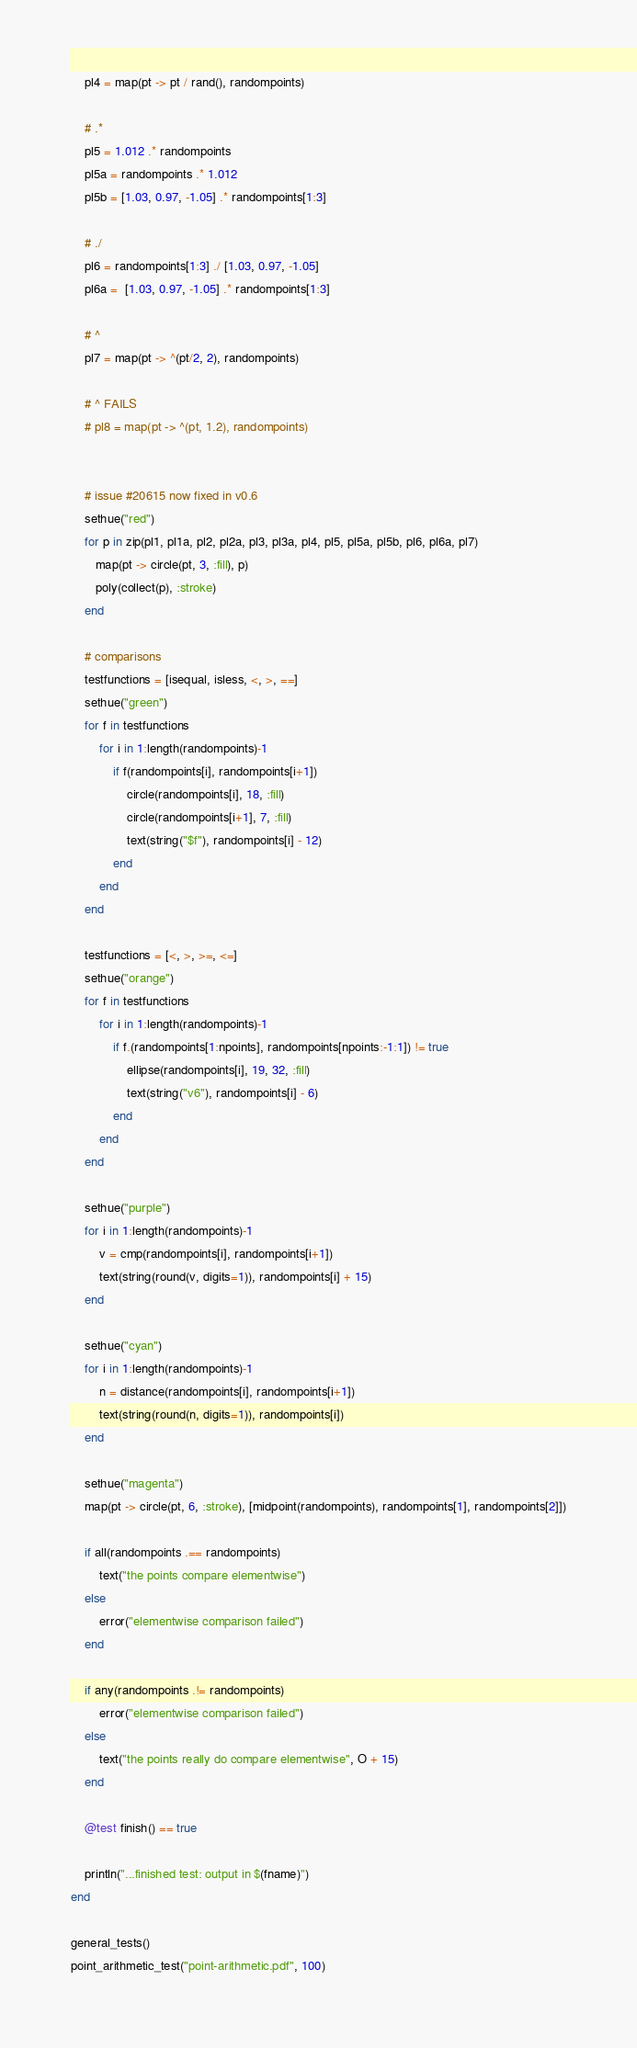<code> <loc_0><loc_0><loc_500><loc_500><_Julia_>    pl4 = map(pt -> pt / rand(), randompoints)

    # .*
    pl5 = 1.012 .* randompoints
    pl5a = randompoints .* 1.012
    pl5b = [1.03, 0.97, -1.05] .* randompoints[1:3]

    # ./
    pl6 = randompoints[1:3] ./ [1.03, 0.97, -1.05]
    pl6a =  [1.03, 0.97, -1.05] .* randompoints[1:3]

    # ^
    pl7 = map(pt -> ^(pt/2, 2), randompoints)

    # ^ FAILS
    # pl8 = map(pt -> ^(pt, 1.2), randompoints)


    # issue #20615 now fixed in v0.6
    sethue("red")
    for p in zip(pl1, pl1a, pl2, pl2a, pl3, pl3a, pl4, pl5, pl5a, pl5b, pl6, pl6a, pl7)
       map(pt -> circle(pt, 3, :fill), p)
       poly(collect(p), :stroke)
    end

    # comparisons
    testfunctions = [isequal, isless, <, >, ==]
    sethue("green")
    for f in testfunctions
        for i in 1:length(randompoints)-1
            if f(randompoints[i], randompoints[i+1])
                circle(randompoints[i], 18, :fill)
                circle(randompoints[i+1], 7, :fill)
                text(string("$f"), randompoints[i] - 12)
            end
        end
    end

    testfunctions = [<, >, >=, <=]
    sethue("orange")
    for f in testfunctions
        for i in 1:length(randompoints)-1
            if f.(randompoints[1:npoints], randompoints[npoints:-1:1]) != true
                ellipse(randompoints[i], 19, 32, :fill)
                text(string("v6"), randompoints[i] - 6)
            end
        end
    end

    sethue("purple")
    for i in 1:length(randompoints)-1
        v = cmp(randompoints[i], randompoints[i+1])
        text(string(round(v, digits=1)), randompoints[i] + 15)
    end

    sethue("cyan")
    for i in 1:length(randompoints)-1
        n = distance(randompoints[i], randompoints[i+1])
        text(string(round(n, digits=1)), randompoints[i])
    end

    sethue("magenta")
    map(pt -> circle(pt, 6, :stroke), [midpoint(randompoints), randompoints[1], randompoints[2]])

    if all(randompoints .== randompoints)
        text("the points compare elementwise")
    else
        error("elementwise comparison failed")
    end

    if any(randompoints .!= randompoints)
        error("elementwise comparison failed")
    else
        text("the points really do compare elementwise", O + 15)
    end

    @test finish() == true

    println("...finished test: output in $(fname)")
end

general_tests()
point_arithmetic_test("point-arithmetic.pdf", 100)
</code> 